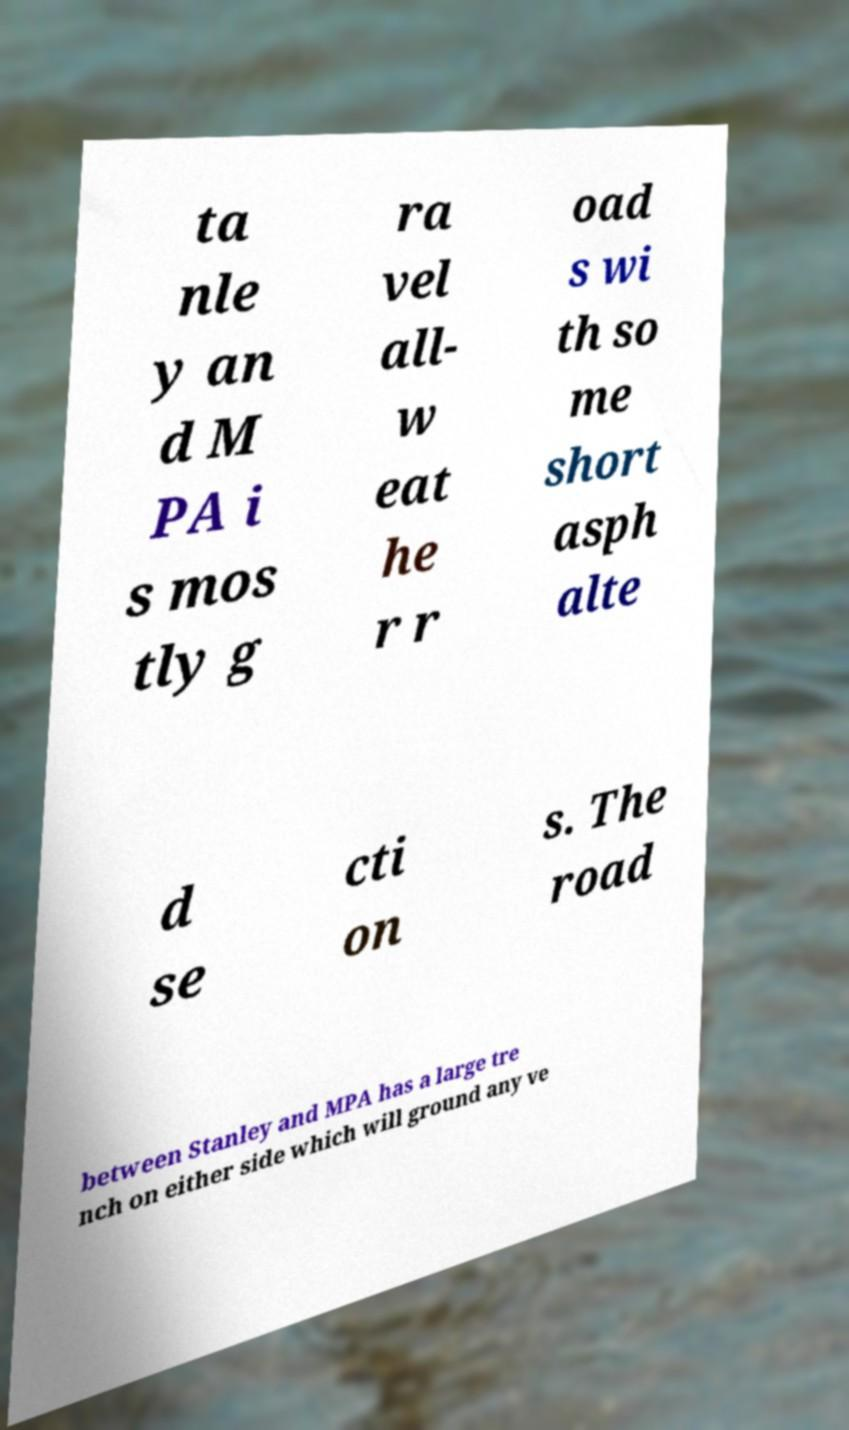For documentation purposes, I need the text within this image transcribed. Could you provide that? ta nle y an d M PA i s mos tly g ra vel all- w eat he r r oad s wi th so me short asph alte d se cti on s. The road between Stanley and MPA has a large tre nch on either side which will ground any ve 